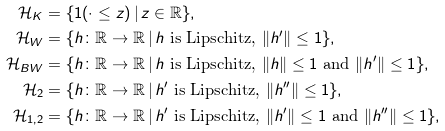<formula> <loc_0><loc_0><loc_500><loc_500>\mathcal { H } _ { K } & = \{ 1 ( \cdot \leq z ) \, | \, z \in \mathbb { R } \} , \\ \mathcal { H } _ { W } & = \{ h \colon \mathbb { R } \rightarrow \mathbb { R } \, | \, \text {$h$ is Lipschitz, $\|h^{\prime}\|\leq1$} \} , \\ \mathcal { H } _ { B W } & = \{ h \colon \mathbb { R } \rightarrow \mathbb { R } \, | \, \text {$h$ is Lipschitz, $\|h\|\leq1$ and $\|h^{\prime}\|\leq1$} \} , \\ \mathcal { H } _ { 2 } & = \{ h \colon \mathbb { R } \rightarrow \mathbb { R } \, | \, \text {$h^{\prime}$ is Lipschitz, $\|h^{\prime\prime}\|\leq1$} \} , \\ \mathcal { H } _ { 1 , 2 } & = \{ h \colon \mathbb { R } \rightarrow \mathbb { R } \, | \, \text {$h^{\prime}$ is Lipschitz, $\|h^{\prime}\|\leq1$ and $\|h^{\prime\prime}\|\leq1$} \} ,</formula> 